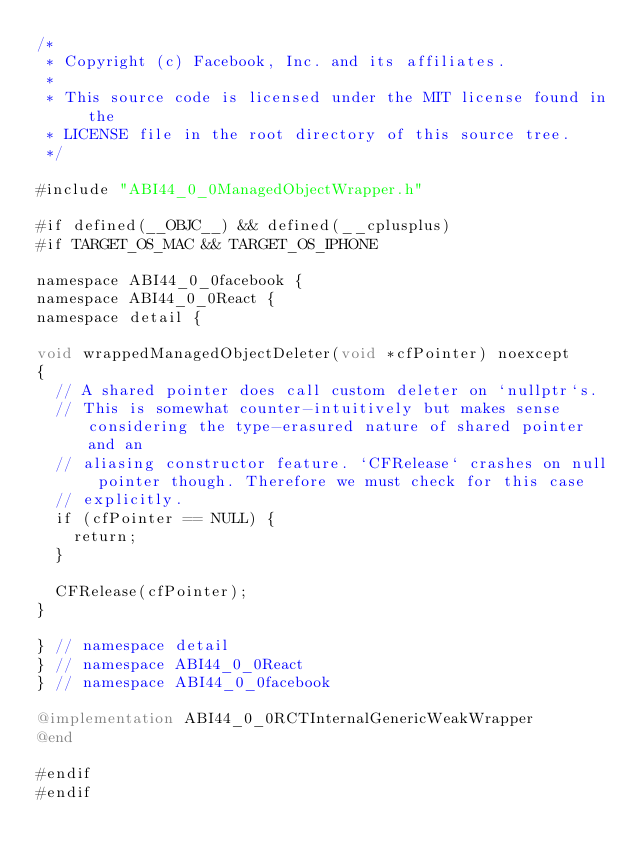Convert code to text. <code><loc_0><loc_0><loc_500><loc_500><_ObjectiveC_>/*
 * Copyright (c) Facebook, Inc. and its affiliates.
 *
 * This source code is licensed under the MIT license found in the
 * LICENSE file in the root directory of this source tree.
 */

#include "ABI44_0_0ManagedObjectWrapper.h"

#if defined(__OBJC__) && defined(__cplusplus)
#if TARGET_OS_MAC && TARGET_OS_IPHONE

namespace ABI44_0_0facebook {
namespace ABI44_0_0React {
namespace detail {

void wrappedManagedObjectDeleter(void *cfPointer) noexcept
{
  // A shared pointer does call custom deleter on `nullptr`s.
  // This is somewhat counter-intuitively but makes sense considering the type-erasured nature of shared pointer and an
  // aliasing constructor feature. `CFRelease` crashes on null pointer though. Therefore we must check for this case
  // explicitly.
  if (cfPointer == NULL) {
    return;
  }

  CFRelease(cfPointer);
}

} // namespace detail
} // namespace ABI44_0_0React
} // namespace ABI44_0_0facebook

@implementation ABI44_0_0RCTInternalGenericWeakWrapper
@end

#endif
#endif
</code> 